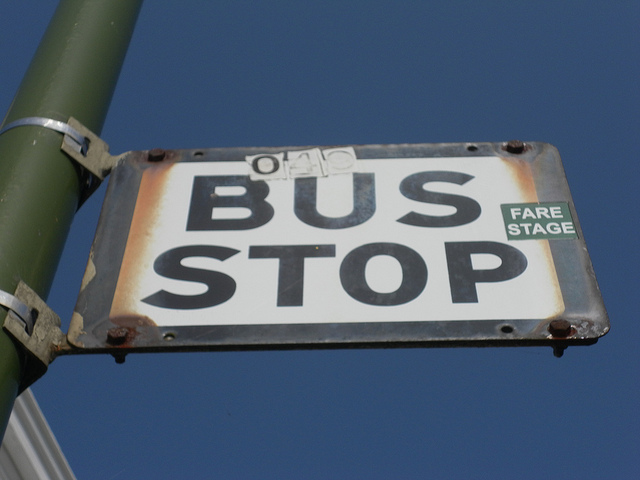Identify and read out the text in this image. BUS STOP FARE STAGE 